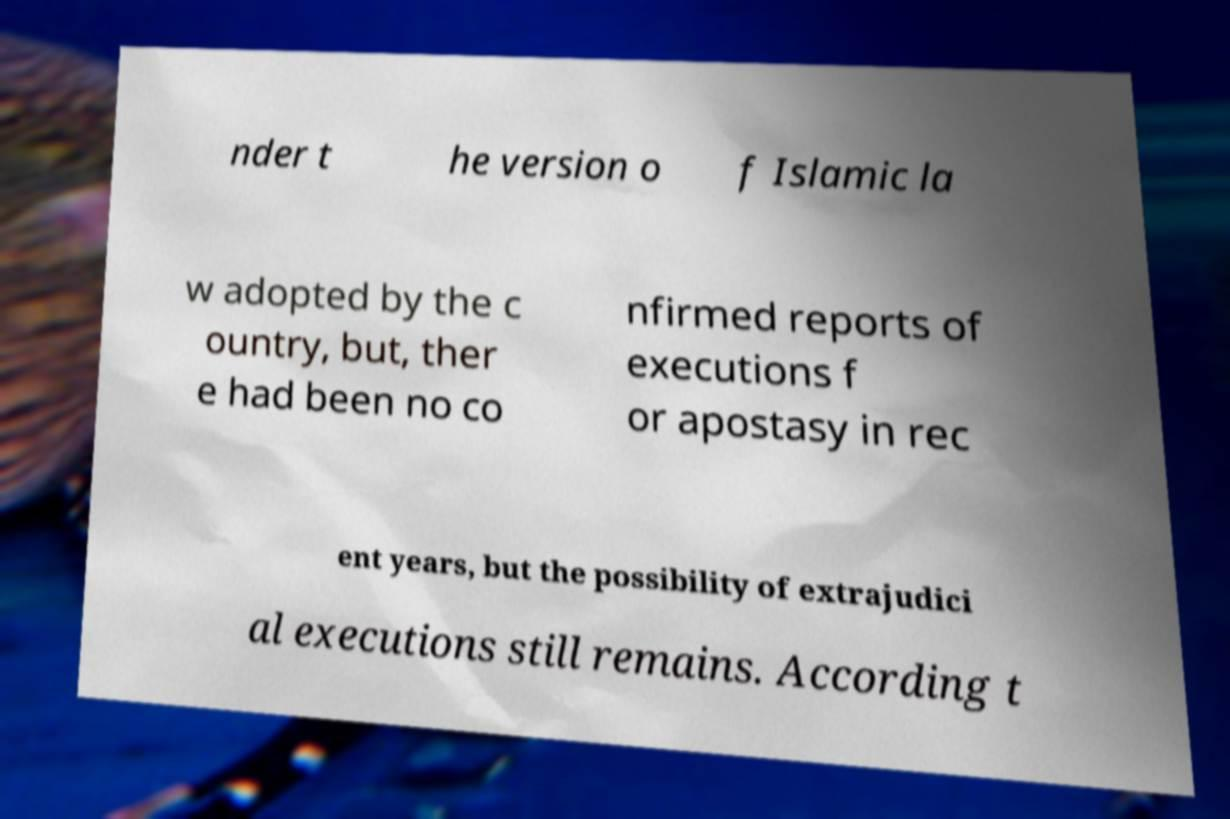Please read and relay the text visible in this image. What does it say? nder t he version o f Islamic la w adopted by the c ountry, but, ther e had been no co nfirmed reports of executions f or apostasy in rec ent years, but the possibility of extrajudici al executions still remains. According t 